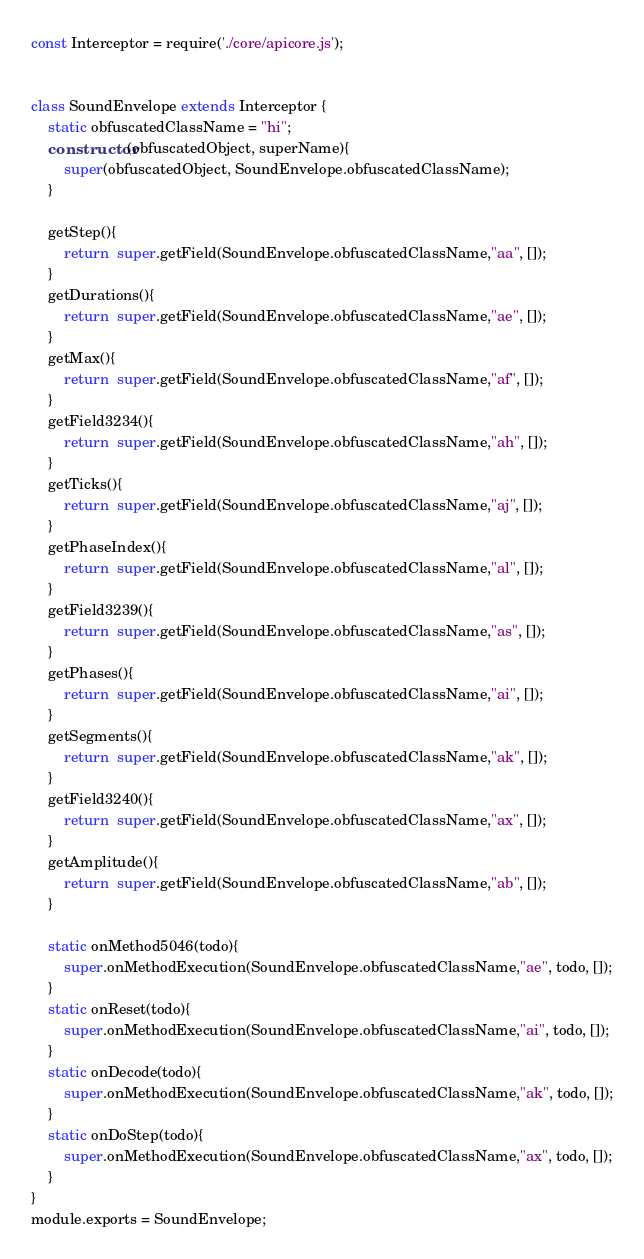<code> <loc_0><loc_0><loc_500><loc_500><_JavaScript_>const Interceptor = require('./core/apicore.js');


class SoundEnvelope extends Interceptor {
	static obfuscatedClassName = "hi";
	constructor(obfuscatedObject, superName){
		super(obfuscatedObject, SoundEnvelope.obfuscatedClassName);
	}

	getStep(){
		return  super.getField(SoundEnvelope.obfuscatedClassName,"aa", []);
	}
	getDurations(){
		return  super.getField(SoundEnvelope.obfuscatedClassName,"ae", []);
	}
	getMax(){
		return  super.getField(SoundEnvelope.obfuscatedClassName,"af", []);
	}
	getField3234(){
		return  super.getField(SoundEnvelope.obfuscatedClassName,"ah", []);
	}
	getTicks(){
		return  super.getField(SoundEnvelope.obfuscatedClassName,"aj", []);
	}
	getPhaseIndex(){
		return  super.getField(SoundEnvelope.obfuscatedClassName,"al", []);
	}
	getField3239(){
		return  super.getField(SoundEnvelope.obfuscatedClassName,"as", []);
	}
	getPhases(){
		return  super.getField(SoundEnvelope.obfuscatedClassName,"ai", []);
	}
	getSegments(){
		return  super.getField(SoundEnvelope.obfuscatedClassName,"ak", []);
	}
	getField3240(){
		return  super.getField(SoundEnvelope.obfuscatedClassName,"ax", []);
	}
	getAmplitude(){
		return  super.getField(SoundEnvelope.obfuscatedClassName,"ab", []);
	}

	static onMethod5046(todo){
		super.onMethodExecution(SoundEnvelope.obfuscatedClassName,"ae", todo, []);
	}
	static onReset(todo){
		super.onMethodExecution(SoundEnvelope.obfuscatedClassName,"ai", todo, []);
	}
	static onDecode(todo){
		super.onMethodExecution(SoundEnvelope.obfuscatedClassName,"ak", todo, []);
	}
	static onDoStep(todo){
		super.onMethodExecution(SoundEnvelope.obfuscatedClassName,"ax", todo, []);
	}
}
module.exports = SoundEnvelope;
</code> 